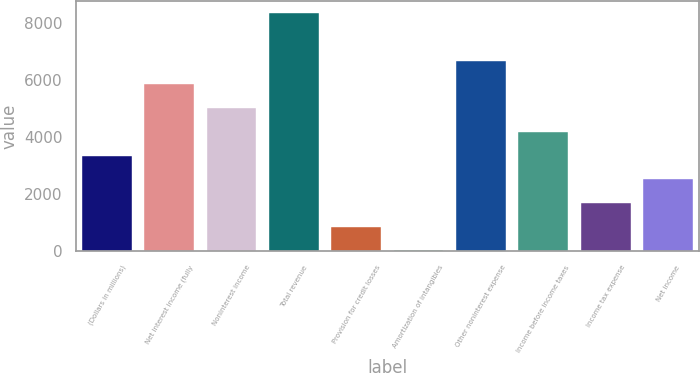Convert chart to OTSL. <chart><loc_0><loc_0><loc_500><loc_500><bar_chart><fcel>(Dollars in millions)<fcel>Net interest income (fully<fcel>Noninterest income<fcel>Total revenue<fcel>Provision for credit losses<fcel>Amortization of intangibles<fcel>Other noninterest expense<fcel>Income before income taxes<fcel>Income tax expense<fcel>Net income<nl><fcel>3348<fcel>5841<fcel>5010<fcel>8334<fcel>855<fcel>24<fcel>6672<fcel>4179<fcel>1686<fcel>2517<nl></chart> 